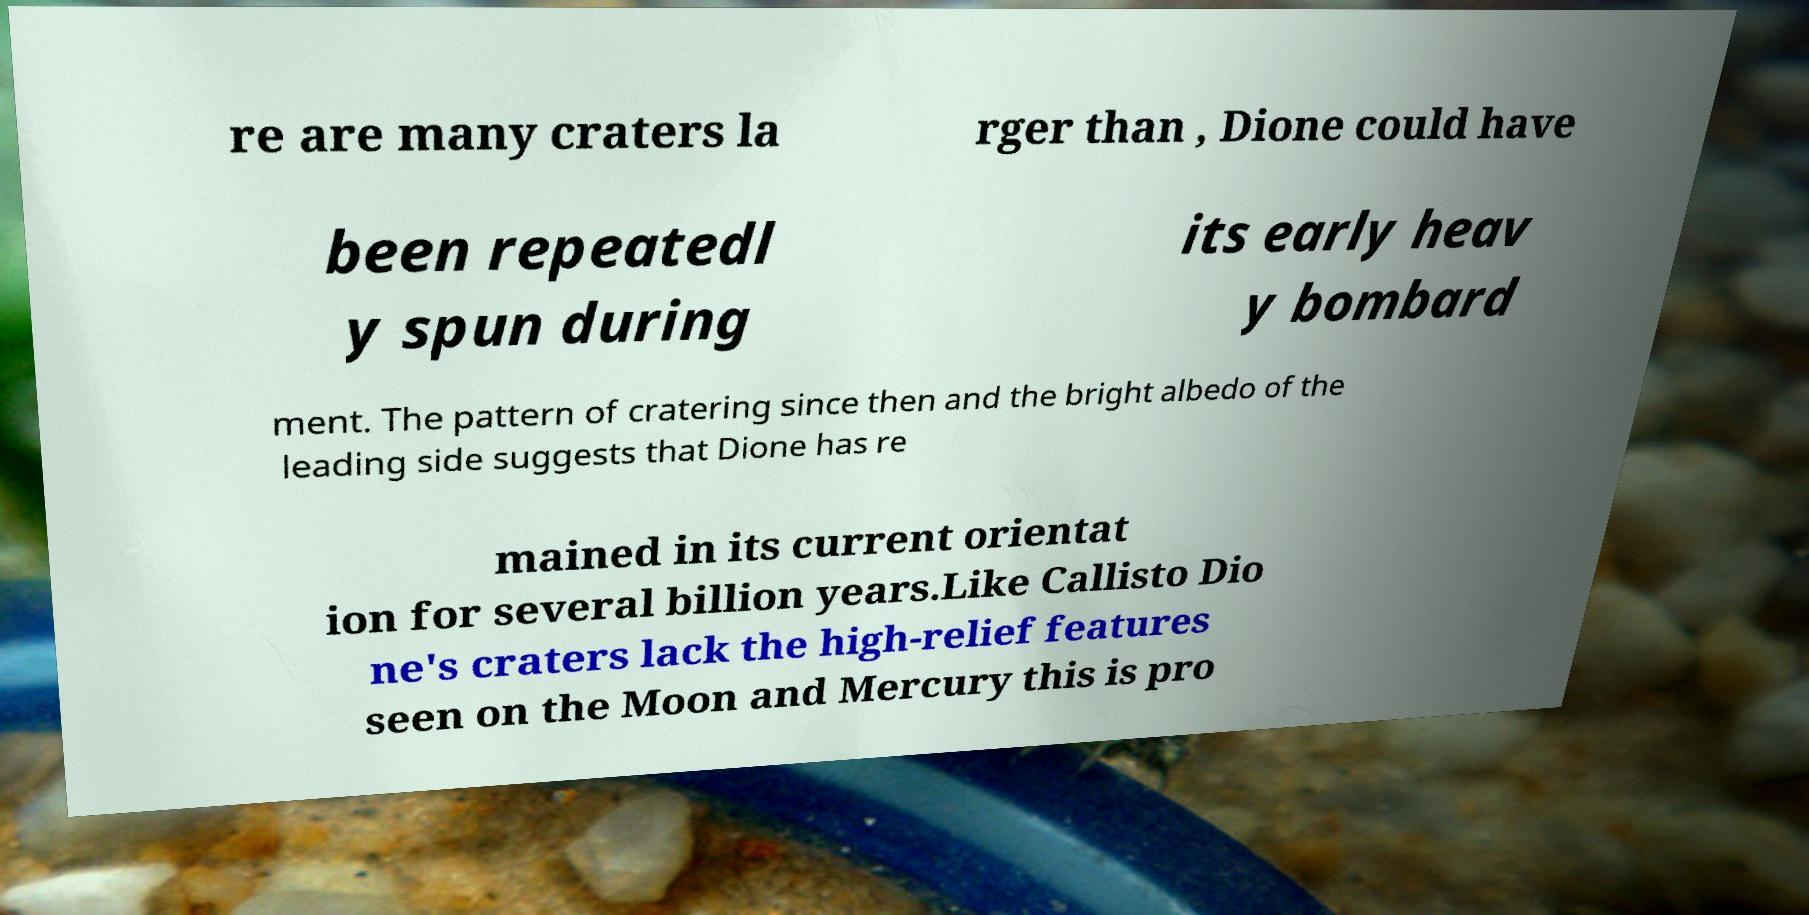Can you read and provide the text displayed in the image?This photo seems to have some interesting text. Can you extract and type it out for me? re are many craters la rger than , Dione could have been repeatedl y spun during its early heav y bombard ment. The pattern of cratering since then and the bright albedo of the leading side suggests that Dione has re mained in its current orientat ion for several billion years.Like Callisto Dio ne's craters lack the high-relief features seen on the Moon and Mercury this is pro 